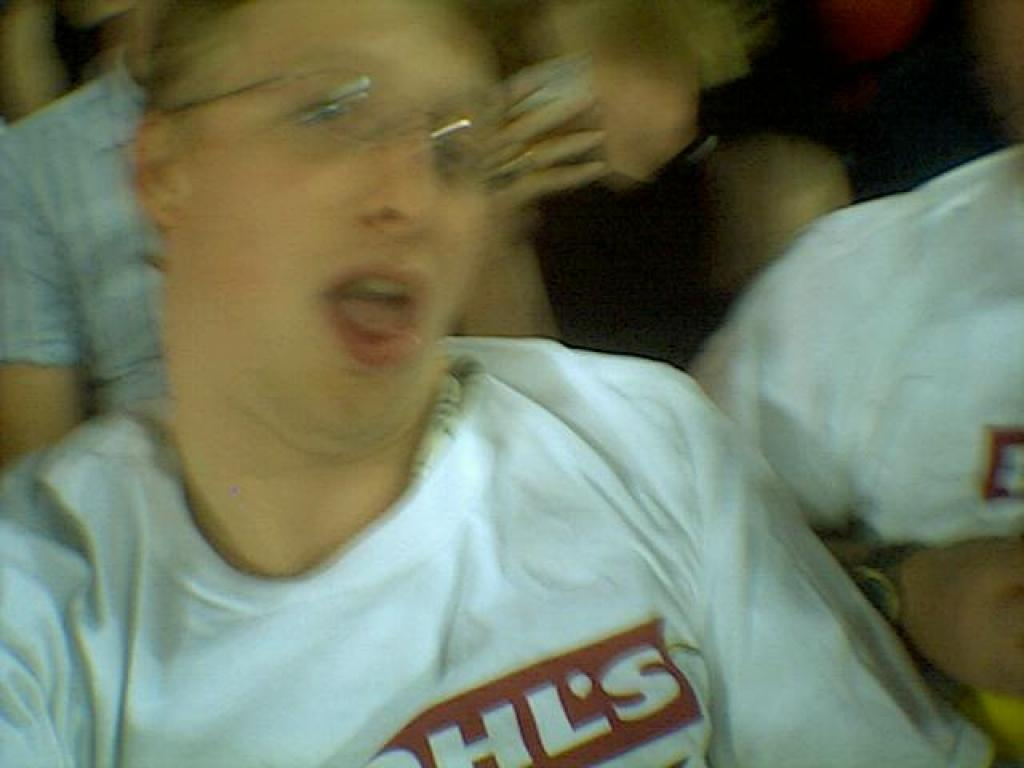What are the people in the image doing? The people in the image are sitting. Can you describe the background of the image? The background of the image is blurred. What riddle is the person in the image trying to solve? There is no riddle present in the image; the people are simply sitting. 